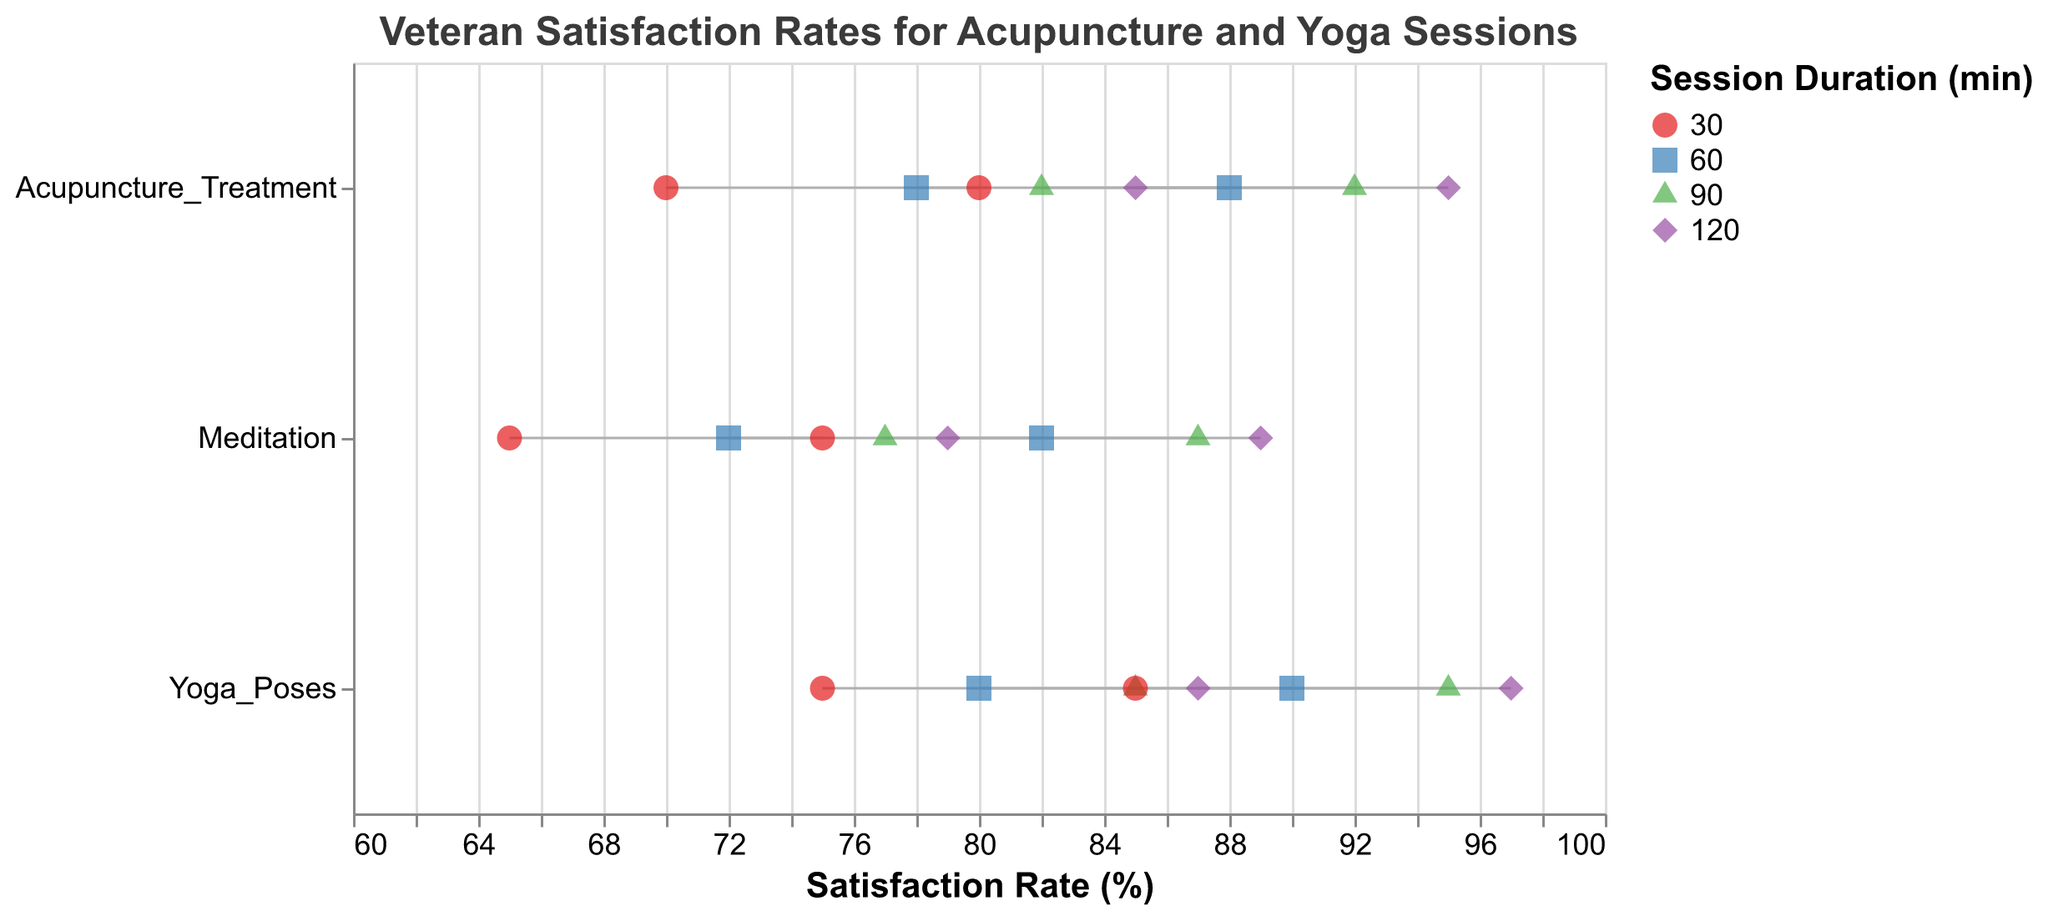What is the maximum satisfaction rate for Yoga Poses in 30-minute sessions? From the plot, look at the range for Yoga Poses under the 30-minute Session Duration. The max satisfaction rate there is 85.
Answer: 85 Which aspect shows the highest minimum satisfaction rate in 120-minute sessions? Check the Satisfaction_Rate_Min values for each aspect under the 120-minute Session Duration. The highest minimum value is for Yoga Poses at 87.
Answer: Yoga Poses How does the maximum satisfaction rate for Meditation change from 30-minute to 120-minute sessions? Look at the Satisfaction_Rate_Max for Meditation across the different session durations. The values are 75 for 30 minutes, 82 for 60 minutes, 87 for 90 minutes, and 89 for 120 minutes. Therefore, it increases from 75 to 89.
Answer: It increases from 75 to 89 Which aspect has the smallest range of satisfaction rates in 30-minute sessions? Calculate the range (Satisfaction_Rate_Max - Satisfaction_Rate_Min) for each aspect in 30-minute sessions. Yoga Poses has a range of 10, Acupuncture Treatment has a range of 10, and Meditation also has a range of 10, so none is smaller than the others.
Answer: None; all are equal Are there any aspects where the satisfaction rates consistently increase with session duration? Check if the Satisfaction_Rate_Min and Satisfaction_Rate_Max values for any aspect increase as the session duration increases. Yoga Poses, Acupuncture Treatment, and Meditation all show increasing trends in both min and max satisfaction rates with longer sessions.
Answer: Yes, all aspects (Yoga Poses, Acupuncture Treatment, and Meditation) What is the average of the minimum satisfaction rates for Acupuncture Treatment across all session durations? Take the Satisfaction_Rate_Min for Acupuncture Treatment across all durations: 70, 78, 82, 85. Sum these values (70+78+82+85) = 315, and divide by the number of values (4).
Answer: 78.75 Between 60-minute and 90-minute sessions, which aspect shows a greater increase in maximum satisfaction for Yoga Poses? The maximum satisfaction rate for Yoga Poses is 90 in 60-minute sessions and 95 in 90-minute sessions. The difference is 95-90, which is 5.
Answer: 5 Does Yoga Poses ever have a lower maximum satisfaction rate than Meditation across any session duration? Check the Satisfaction_Rate_Max for Yoga Poses and Meditation at each session duration. For all sessions (30, 60, 90, 120 minutes), Yoga Poses always has a higher or equal max satisfaction rate compared to Meditation.
Answer: No Which session duration provides the highest minimum satisfaction rate for any aspect? Look at the Satisfaction_Rate_Min for all aspects across all session durations. The highest value is 87 for Yoga Poses in 120-minute sessions.
Answer: 120-minute for Yoga Poses 